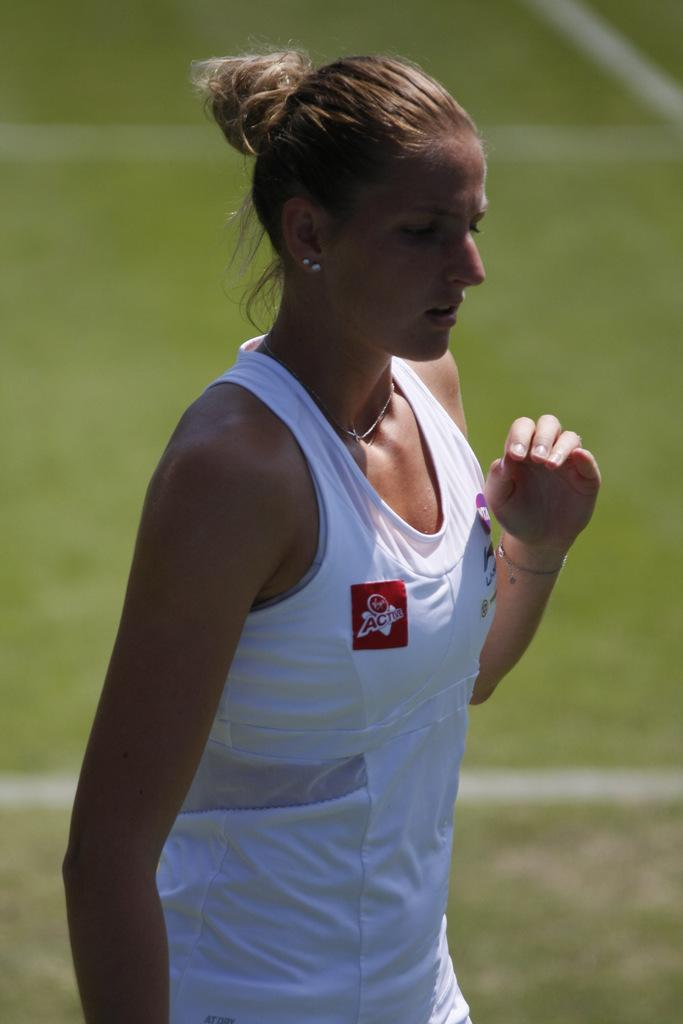Who is the main subject in the image? There is a woman in the image. What is the woman doing in the image? The woman is standing. What is the woman wearing in the image? The woman is wearing a white dress. What can be seen in the background of the image? The background of the image appears green in color. What scent is emanating from the woman's eye in the image? There is no mention of a scent or any reference to the woman's eye in the image, so it cannot be determined. 